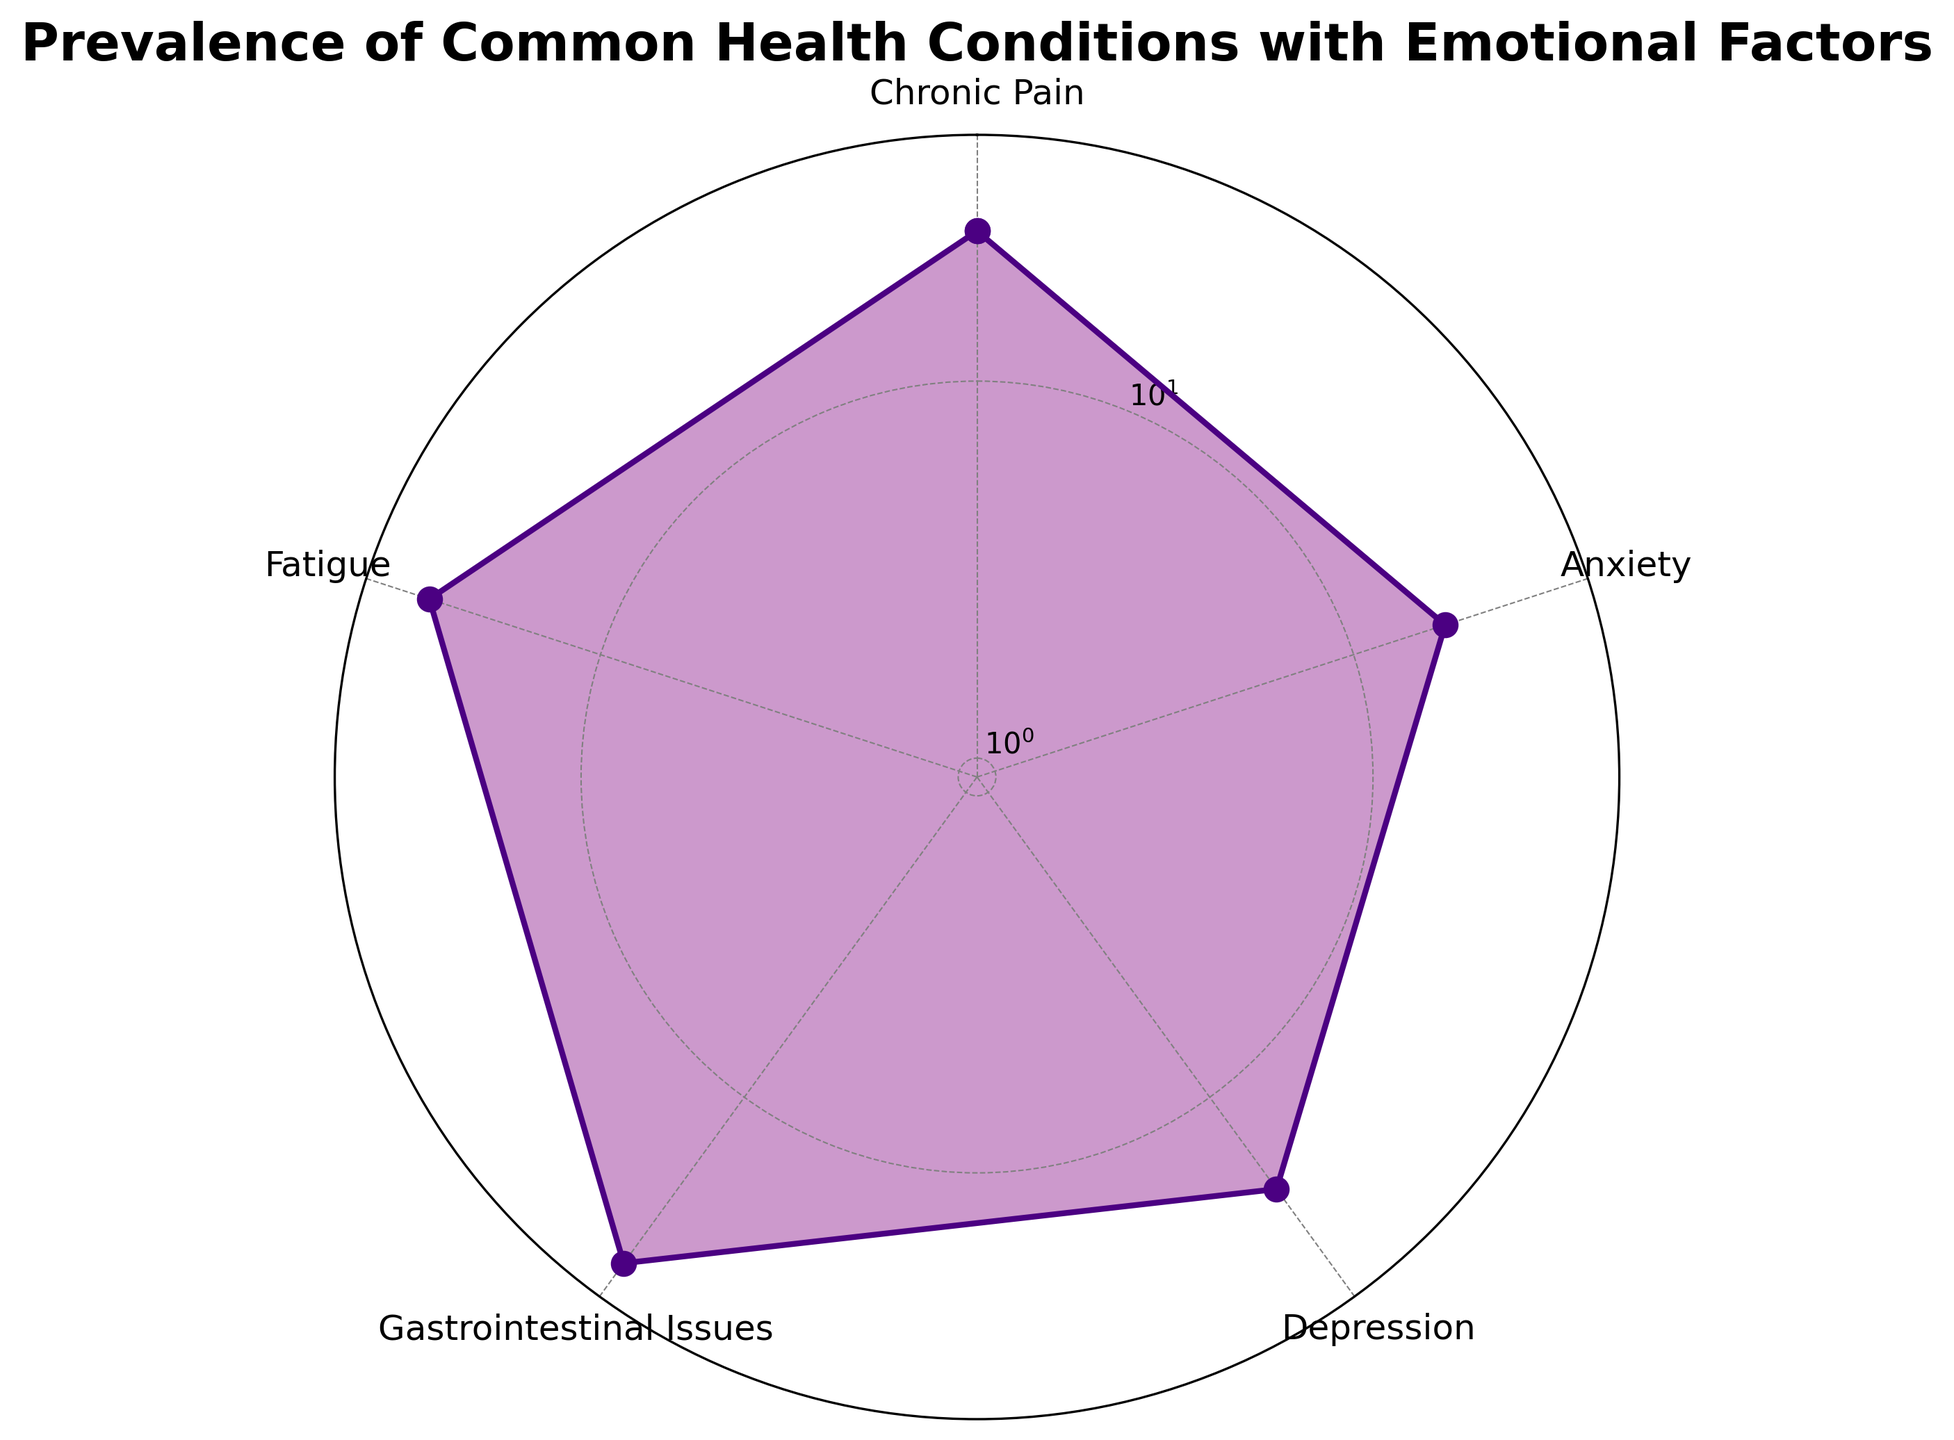Which condition has the highest prevalence? The radar chart shows that 'Gastrointestinal Issues' has the longest distance from the center, indicating the highest prevalence percentage among the conditions.
Answer: Gastrointestinal Issues Which condition has the lowest prevalence? The radar chart indicates that 'Anxiety' occupies the smallest section, meaning it has the lowest prevalence percentage among the conditions.
Answer: Anxiety What is the prevalence difference between Fatigue and Chronic Pain? The radar chart displays a prevalence percentage of 30% for Fatigue and 25% for Chronic Pain. Subtracting the two gives 30% - 25%.
Answer: 5% How many conditions have a prevalence percentage greater than 20%? By inspecting the radar chart, 'Chronic Pain', 'Gastrointestinal Issues', and 'Fatigue' all have prevalence percentages greater than 20%. So, there are 3 conditions.
Answer: 3 Compare the prevalence percentages of Anxiety and Depression. Which one is greater? On the radar chart, the prevalence of Depression is at 20%, whereas Anxiety is at 18%. Since 20% is greater than 18%, Depression has the higher prevalence.
Answer: Depression What is the average prevalence percentage of all conditions shown? The radar chart displays the following prevalences: 25% (Chronic Pain), 18% (Anxiety), 20% (Depression), 35% (Gastrointestinal Issues), and 30% (Fatigue). Summing these gives 128%, and dividing by 5 (the number of conditions) provides 25.6%.
Answer: 25.6% Which two conditions have the closest prevalence percentages? By examining the radar chart, Depression (20%) and Anxiety (18%) are closest in prevalence, with a difference of only 2%.
Answer: Depression and Anxiety 